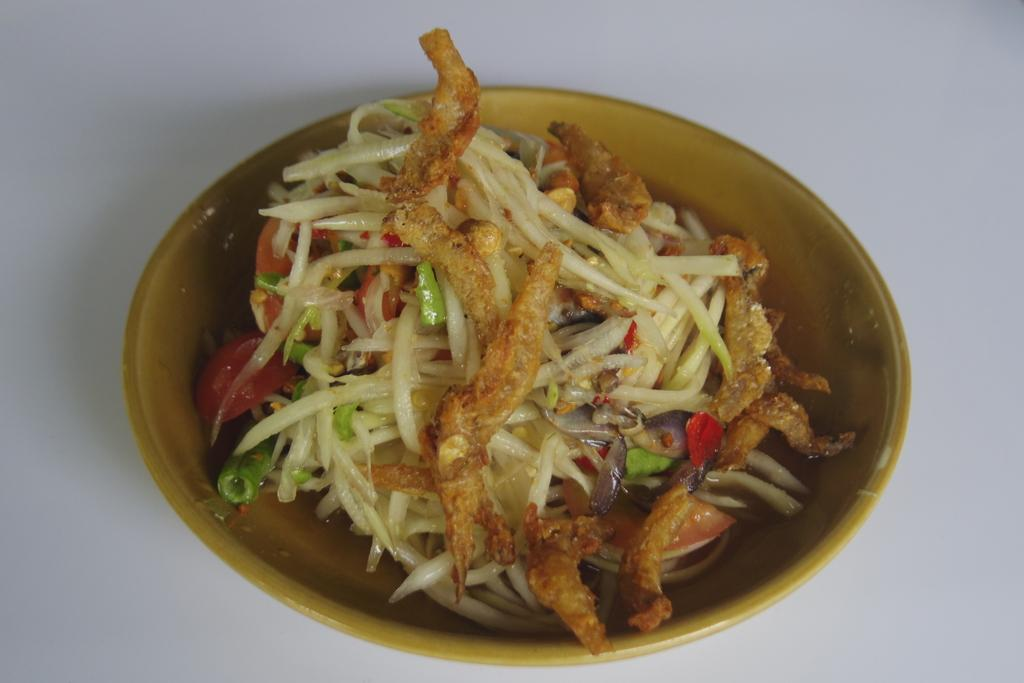What is in the bowl that is visible in the image? There is food in a bowl in the image. Are there any crows interacting with the food in the image? There is no mention of crows or any other animals in the image, so it cannot be determined if they are interacting with the food. 